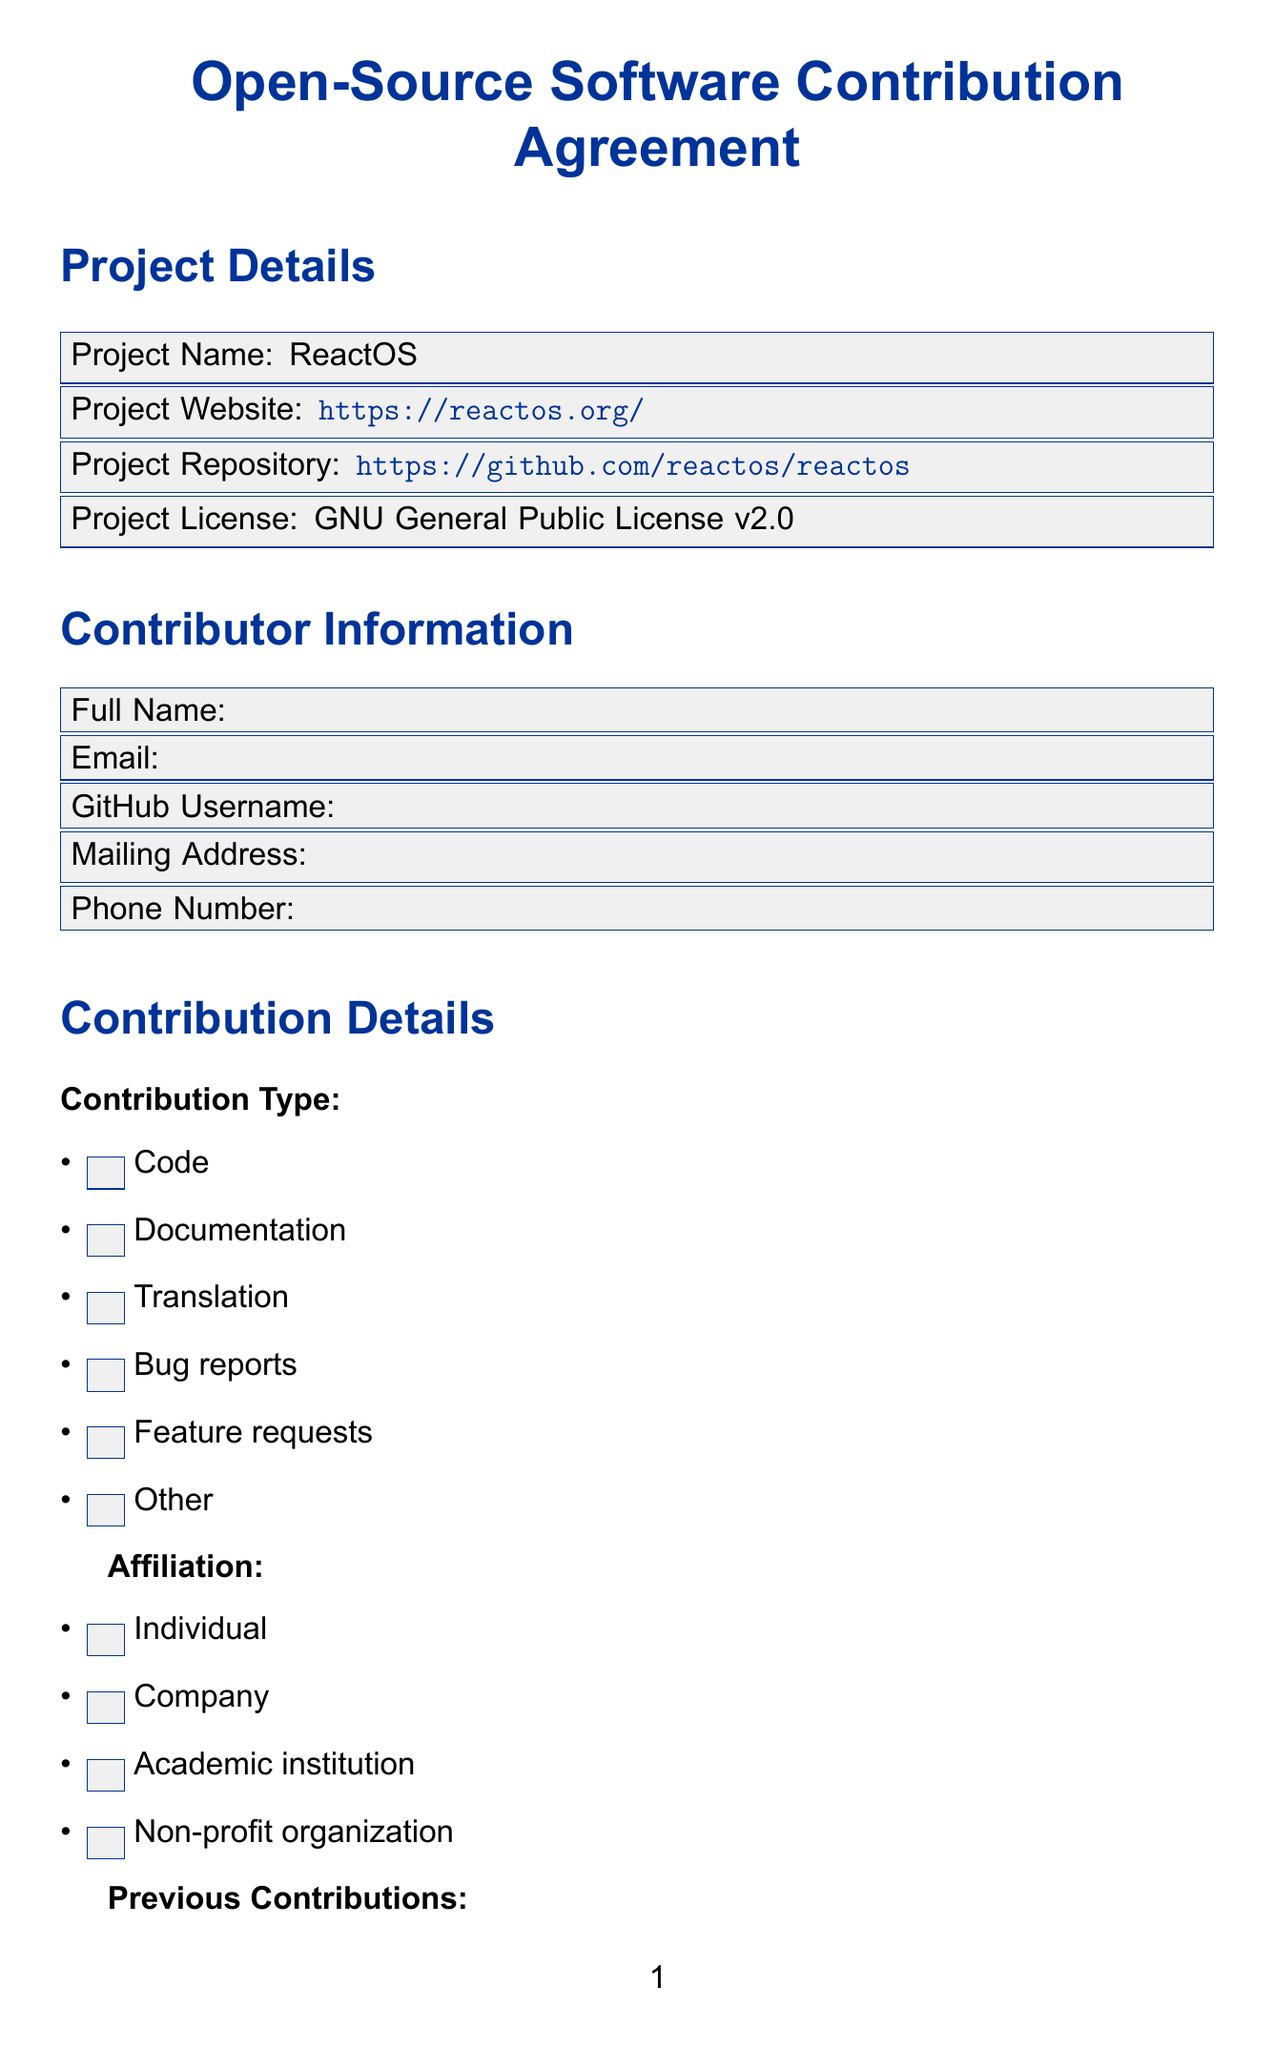What is the project name? The project name is mentioned in the project details section of the document.
Answer: ReactOS What is the project license? The project license is specified in the project details section of the document.
Answer: GNU General Public License v2.0 How many programming languages are listed? The programming languages section contains multiple options for contribution skills; counting them provides the total.
Answer: 5 What does the contributor declare about originality? The originality statement is outlined in the legal agreements section of the document and specifies the contributor's assurance.
Answer: I declare that my contributions are my original creation and to the best of my knowledge do not infringe on any third party's intellectual property rights What are the available contribution types? The contribution types are listed in the contribution details section, indicating the different ways a contributor can help the project.
Answer: Code, Documentation, Translation, Bug reports, Feature requests, Other Who approves the contributions? The approval process is addressed in the project manager approval section, indicating the role responsible for this task.
Answer: Project Manager 